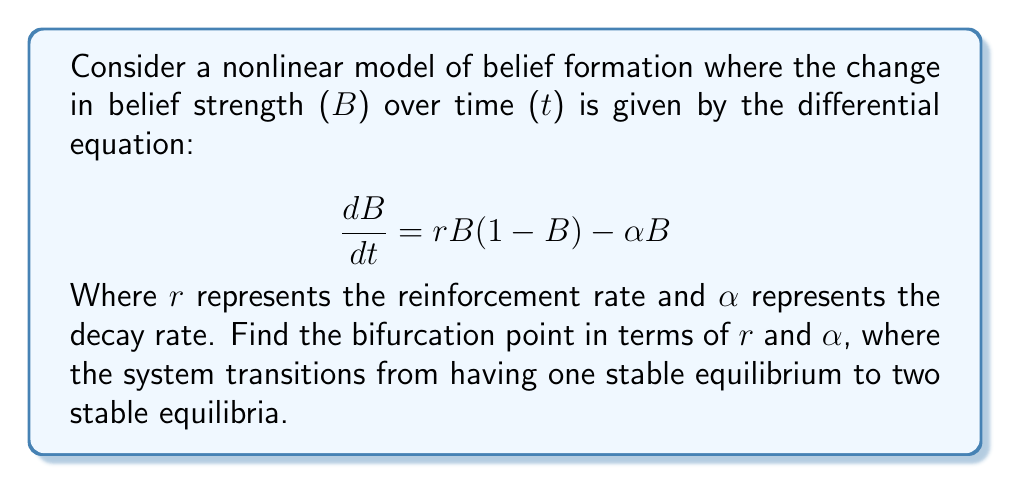Teach me how to tackle this problem. To find the bifurcation point, we need to follow these steps:

1) First, find the equilibria of the system by setting $\frac{dB}{dt} = 0$:

   $$ rB(1-B) - \alpha B = 0 $$

2) Factor out B:

   $$ B(r(1-B) - \alpha) = 0 $$

3) This gives us two solutions: $B = 0$ and $r(1-B) - \alpha = 0$

4) From the second solution:

   $$ r - rB - \alpha = 0 $$
   $$ rB = r - \alpha $$
   $$ B = 1 - \frac{\alpha}{r} $$

5) For this to be a valid equilibrium point, we need $0 < B < 1$, which means:

   $$ 0 < 1 - \frac{\alpha}{r} < 1 $$

6) This inequality simplifies to:

   $$ 0 < r - \alpha < r $$

7) The left inequality gives us $r > \alpha$, which is the condition for the existence of the second equilibrium point.

8) The bifurcation occurs when this second equilibrium point emerges, which happens exactly when:

   $$ r = \alpha $$

This is the bifurcation point, where the system transitions from having one stable equilibrium (B = 0) to two stable equilibria (B = 0 and B = 1 - α/r).
Answer: $r = \alpha$ 